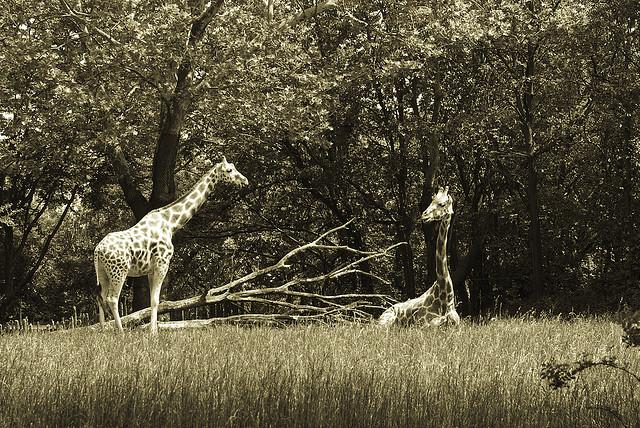How many animals are in this scene?
Be succinct. 2. Has a tree fallen?
Quick response, please. Yes. Are the giraffes laying in tall grass?
Quick response, please. Yes. What animal is in the trees?
Short answer required. Giraffe. Are they held behind a fence?
Answer briefly. No. 